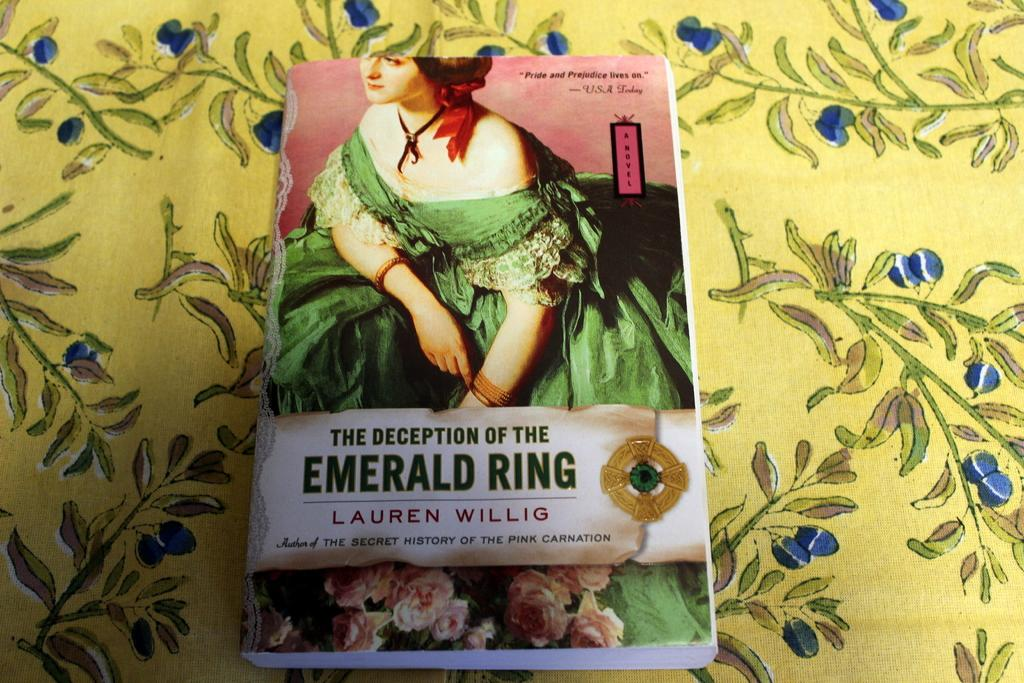What is depicted on the book in the image? There is an image of a woman on the book. How is the woman in the image described? The woman is described as beautiful. What is the woman in the image wearing? The woman is wearing a green saree. What type of corn is being served on the woman's finger in the image? There is no corn or finger present in the image; it features an image of a woman wearing a green saree. 